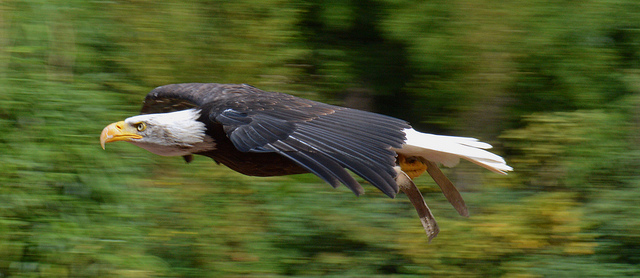<image>Where is this bird flying too? It is unknown where the bird is flying to. It may be flying to a tree, nest or somewhere else. Where is this bird flying too? I don't know where this bird is flying to. It can be flying to its nest or somewhere else. 